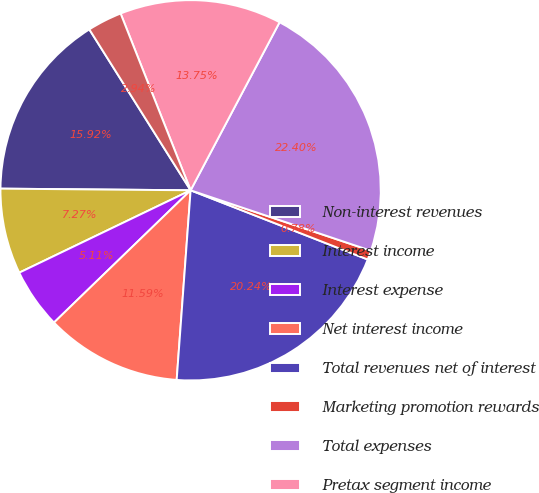<chart> <loc_0><loc_0><loc_500><loc_500><pie_chart><fcel>Non-interest revenues<fcel>Interest income<fcel>Interest expense<fcel>Net interest income<fcel>Total revenues net of interest<fcel>Marketing promotion rewards<fcel>Total expenses<fcel>Pretax segment income<fcel>Income tax provision<nl><fcel>15.92%<fcel>7.27%<fcel>5.11%<fcel>11.59%<fcel>20.24%<fcel>0.78%<fcel>22.4%<fcel>13.75%<fcel>2.94%<nl></chart> 